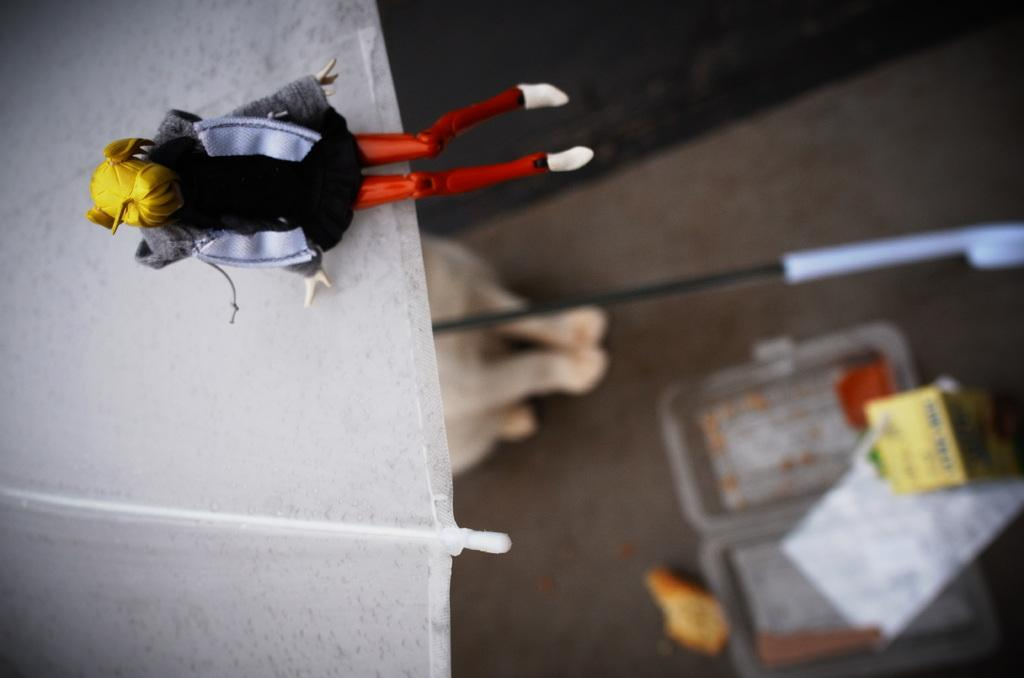What object is located in the foreground of the image? There is an umbrella in the foreground of the image. What is attached to the umbrella? There is a toy on the umbrella. What can be seen on the right side of the image? There is a box on the right side of the image. What items are inside the box? The box contains tablets and pens. What idea or thought is being expressed by the force of the umbrella in the image? There is no idea or thought being expressed by the force of the umbrella in the image, as it is simply an object with a toy attached to it. 